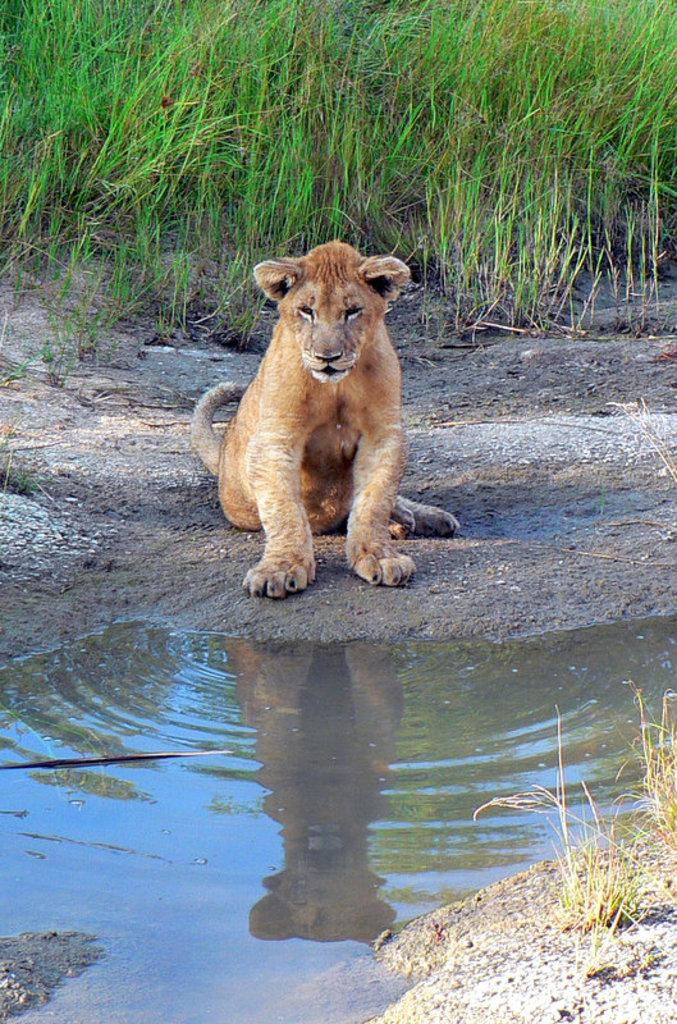What is the main subject in the center of the image? There is a lion in the center of the image. What type of natural environment is visible in the background of the image? There is grass and water visible in the background of the image. What type of mountain can be seen in the background of the image? There is no mountain present in the image; it features a lion in the center and grass and water in the background. 